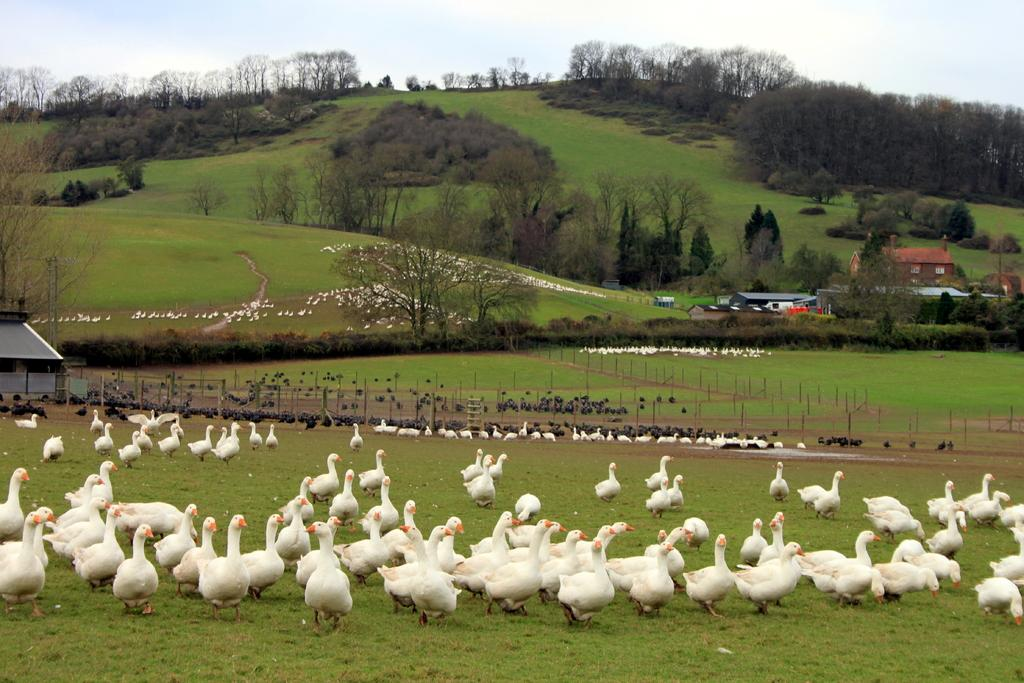What type of vegetation is present in the image? There are trees in the image. What type of structures can be seen in the image? There are houses in the image. What are the poles in the image used for? The purpose of the poles in the image is not specified, but they could be for supporting power lines or other utilities. What type of ground cover is present in the image? There is grass in the image. What part of the natural environment is visible in the image? The sky is visible in the image. What type of animals can be seen in the image? There are birds in the image. Where is the crook hiding in the image? There is no crook present in the image. What type of bean is growing in the image? There are no beans present in the image. 